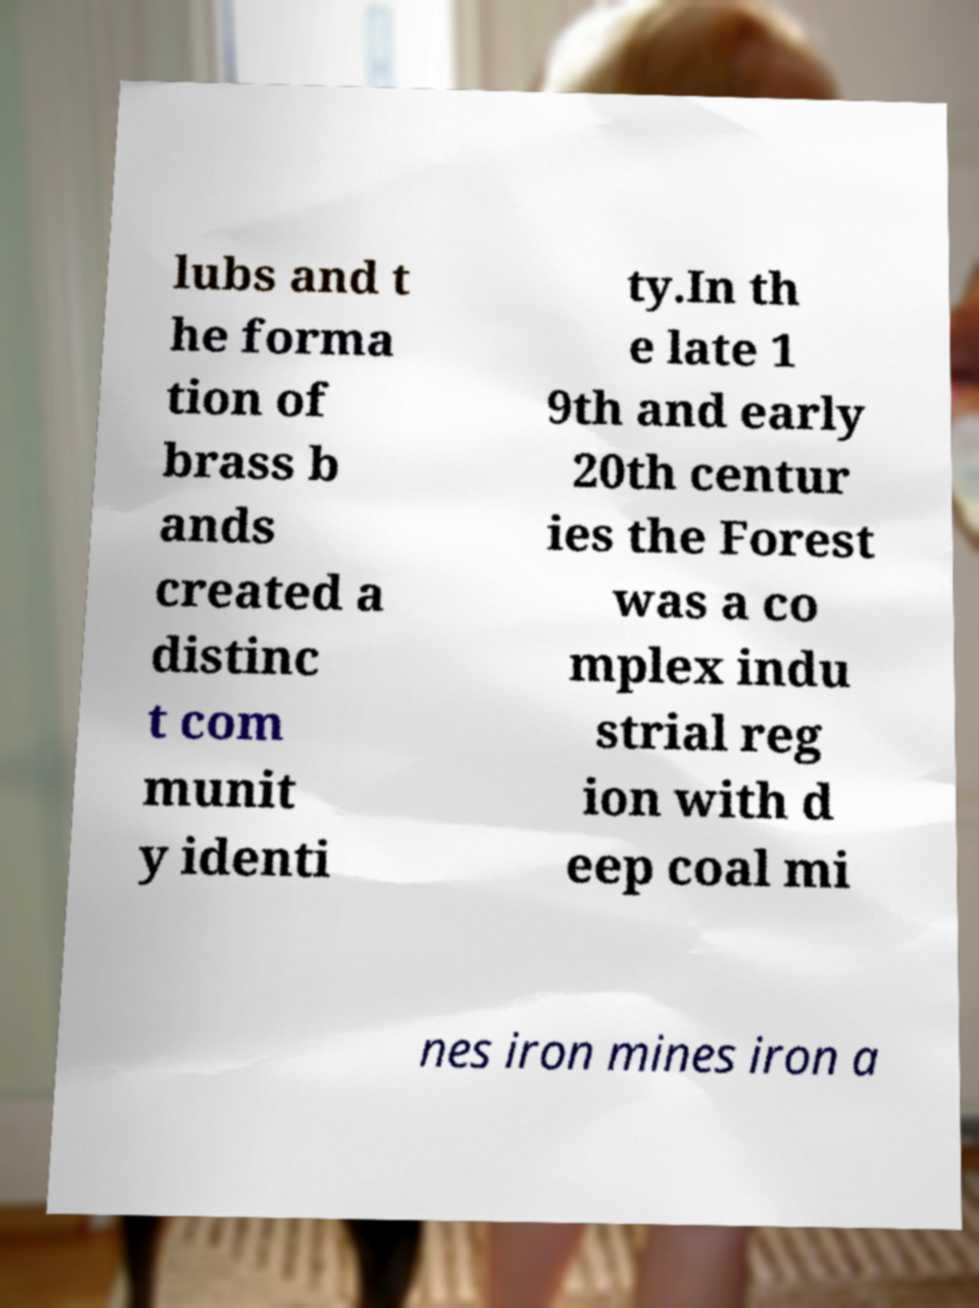Please read and relay the text visible in this image. What does it say? lubs and t he forma tion of brass b ands created a distinc t com munit y identi ty.In th e late 1 9th and early 20th centur ies the Forest was a co mplex indu strial reg ion with d eep coal mi nes iron mines iron a 